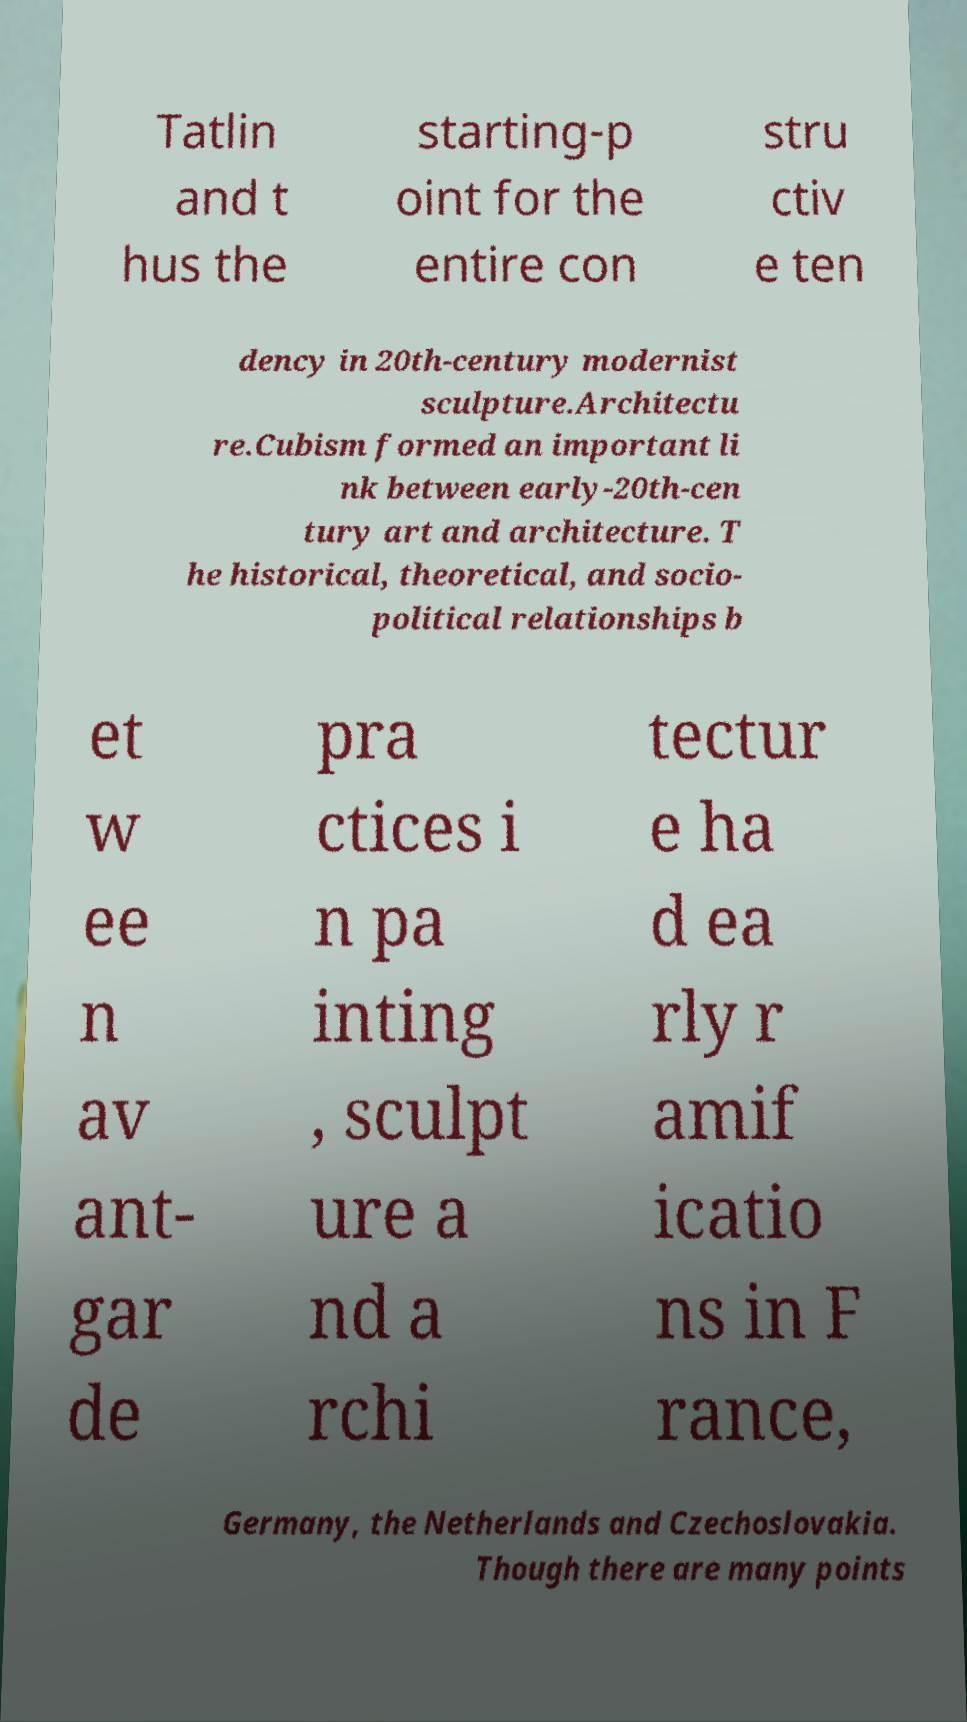For documentation purposes, I need the text within this image transcribed. Could you provide that? Tatlin and t hus the starting-p oint for the entire con stru ctiv e ten dency in 20th-century modernist sculpture.Architectu re.Cubism formed an important li nk between early-20th-cen tury art and architecture. T he historical, theoretical, and socio- political relationships b et w ee n av ant- gar de pra ctices i n pa inting , sculpt ure a nd a rchi tectur e ha d ea rly r amif icatio ns in F rance, Germany, the Netherlands and Czechoslovakia. Though there are many points 